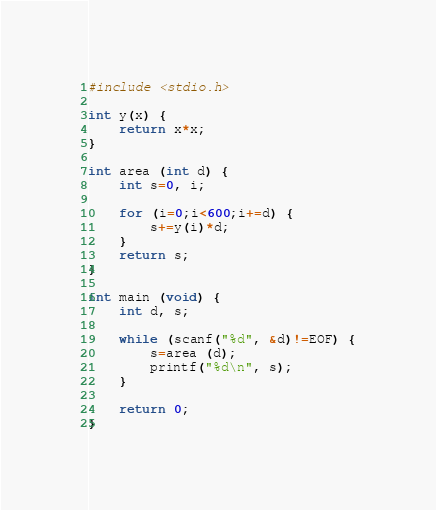Convert code to text. <code><loc_0><loc_0><loc_500><loc_500><_C_>#include <stdio.h>

int y(x) {
    return x*x;
}

int area (int d) {
    int s=0, i;

    for (i=0;i<600;i+=d) {
        s+=y(i)*d;
    }
    return s;
}

int main (void) {
    int d, s;

    while (scanf("%d", &d)!=EOF) {
        s=area (d);
        printf("%d\n", s);
    }

    return 0;
}
</code> 